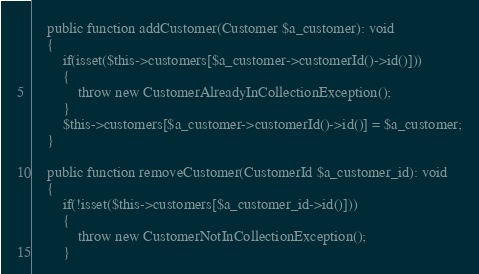Convert code to text. <code><loc_0><loc_0><loc_500><loc_500><_PHP_>    public function addCustomer(Customer $a_customer): void
    {
        if(isset($this->customers[$a_customer->customerId()->id()]))
        {
            throw new CustomerAlreadyInCollectionException();
        }
        $this->customers[$a_customer->customerId()->id()] = $a_customer;
    }

    public function removeCustomer(CustomerId $a_customer_id): void
    {
        if(!isset($this->customers[$a_customer_id->id()]))
        {
            throw new CustomerNotInCollectionException();
        }</code> 